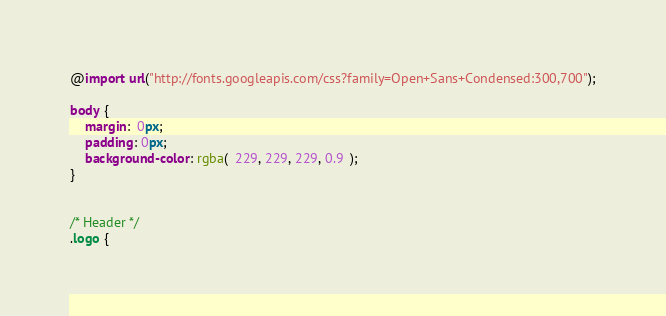Convert code to text. <code><loc_0><loc_0><loc_500><loc_500><_CSS_>@import url("http://fonts.googleapis.com/css?family=Open+Sans+Condensed:300,700");

body {
	margin:  0px;
	padding: 0px;
	background-color: rgba(  229, 229, 229, 0.9  );
}


/* Header */
.logo {</code> 